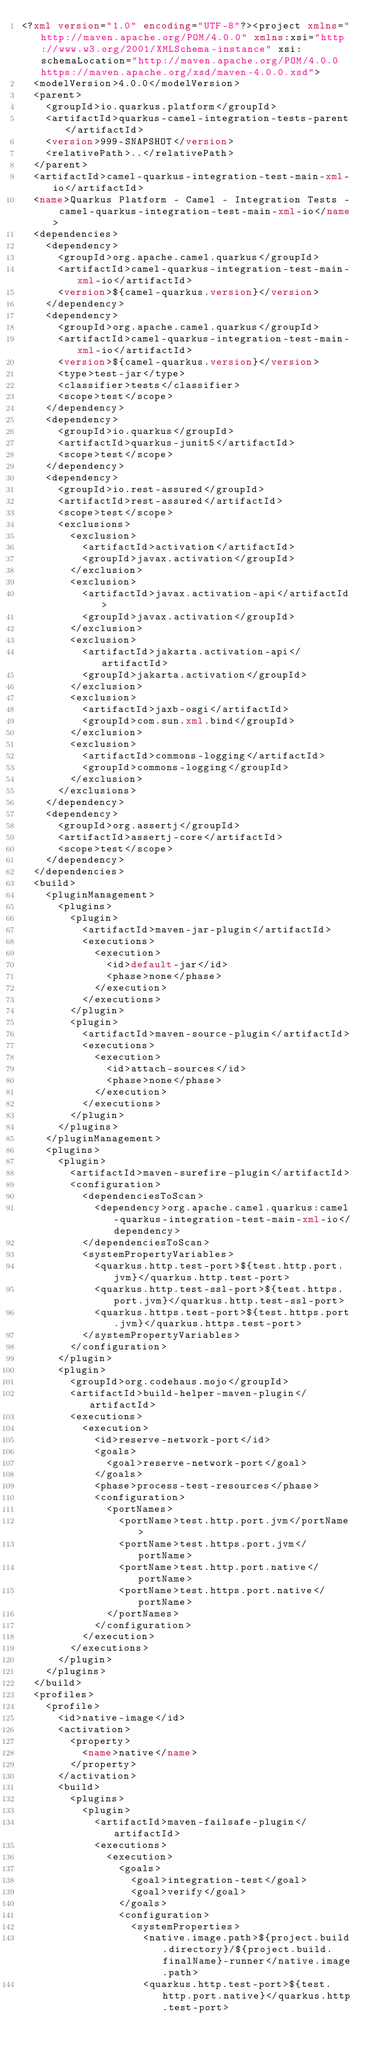<code> <loc_0><loc_0><loc_500><loc_500><_XML_><?xml version="1.0" encoding="UTF-8"?><project xmlns="http://maven.apache.org/POM/4.0.0" xmlns:xsi="http://www.w3.org/2001/XMLSchema-instance" xsi:schemaLocation="http://maven.apache.org/POM/4.0.0 https://maven.apache.org/xsd/maven-4.0.0.xsd">
  <modelVersion>4.0.0</modelVersion>
  <parent>
    <groupId>io.quarkus.platform</groupId>
    <artifactId>quarkus-camel-integration-tests-parent</artifactId>
    <version>999-SNAPSHOT</version>
    <relativePath>..</relativePath>
  </parent>
  <artifactId>camel-quarkus-integration-test-main-xml-io</artifactId>
  <name>Quarkus Platform - Camel - Integration Tests - camel-quarkus-integration-test-main-xml-io</name>
  <dependencies>
    <dependency>
      <groupId>org.apache.camel.quarkus</groupId>
      <artifactId>camel-quarkus-integration-test-main-xml-io</artifactId>
      <version>${camel-quarkus.version}</version>
    </dependency>
    <dependency>
      <groupId>org.apache.camel.quarkus</groupId>
      <artifactId>camel-quarkus-integration-test-main-xml-io</artifactId>
      <version>${camel-quarkus.version}</version>
      <type>test-jar</type>
      <classifier>tests</classifier>
      <scope>test</scope>
    </dependency>
    <dependency>
      <groupId>io.quarkus</groupId>
      <artifactId>quarkus-junit5</artifactId>
      <scope>test</scope>
    </dependency>
    <dependency>
      <groupId>io.rest-assured</groupId>
      <artifactId>rest-assured</artifactId>
      <scope>test</scope>
      <exclusions>
        <exclusion>
          <artifactId>activation</artifactId>
          <groupId>javax.activation</groupId>
        </exclusion>
        <exclusion>
          <artifactId>javax.activation-api</artifactId>
          <groupId>javax.activation</groupId>
        </exclusion>
        <exclusion>
          <artifactId>jakarta.activation-api</artifactId>
          <groupId>jakarta.activation</groupId>
        </exclusion>
        <exclusion>
          <artifactId>jaxb-osgi</artifactId>
          <groupId>com.sun.xml.bind</groupId>
        </exclusion>
        <exclusion>
          <artifactId>commons-logging</artifactId>
          <groupId>commons-logging</groupId>
        </exclusion>
      </exclusions>
    </dependency>
    <dependency>
      <groupId>org.assertj</groupId>
      <artifactId>assertj-core</artifactId>
      <scope>test</scope>
    </dependency>
  </dependencies>
  <build>
    <pluginManagement>
      <plugins>
        <plugin>
          <artifactId>maven-jar-plugin</artifactId>
          <executions>
            <execution>
              <id>default-jar</id>
              <phase>none</phase>
            </execution>
          </executions>
        </plugin>
        <plugin>
          <artifactId>maven-source-plugin</artifactId>
          <executions>
            <execution>
              <id>attach-sources</id>
              <phase>none</phase>
            </execution>
          </executions>
        </plugin>
      </plugins>
    </pluginManagement>
    <plugins>
      <plugin>
        <artifactId>maven-surefire-plugin</artifactId>
        <configuration>
          <dependenciesToScan>
            <dependency>org.apache.camel.quarkus:camel-quarkus-integration-test-main-xml-io</dependency>
          </dependenciesToScan>
          <systemPropertyVariables>
            <quarkus.http.test-port>${test.http.port.jvm}</quarkus.http.test-port>
            <quarkus.http.test-ssl-port>${test.https.port.jvm}</quarkus.http.test-ssl-port>
            <quarkus.https.test-port>${test.https.port.jvm}</quarkus.https.test-port>
          </systemPropertyVariables>
        </configuration>
      </plugin>
      <plugin>
        <groupId>org.codehaus.mojo</groupId>
        <artifactId>build-helper-maven-plugin</artifactId>
        <executions>
          <execution>
            <id>reserve-network-port</id>
            <goals>
              <goal>reserve-network-port</goal>
            </goals>
            <phase>process-test-resources</phase>
            <configuration>
              <portNames>
                <portName>test.http.port.jvm</portName>
                <portName>test.https.port.jvm</portName>
                <portName>test.http.port.native</portName>
                <portName>test.https.port.native</portName>
              </portNames>
            </configuration>
          </execution>
        </executions>
      </plugin>
    </plugins>
  </build>
  <profiles>
    <profile>
      <id>native-image</id>
      <activation>
        <property>
          <name>native</name>
        </property>
      </activation>
      <build>
        <plugins>
          <plugin>
            <artifactId>maven-failsafe-plugin</artifactId>
            <executions>
              <execution>
                <goals>
                  <goal>integration-test</goal>
                  <goal>verify</goal>
                </goals>
                <configuration>
                  <systemProperties>
                    <native.image.path>${project.build.directory}/${project.build.finalName}-runner</native.image.path>
                    <quarkus.http.test-port>${test.http.port.native}</quarkus.http.test-port></code> 